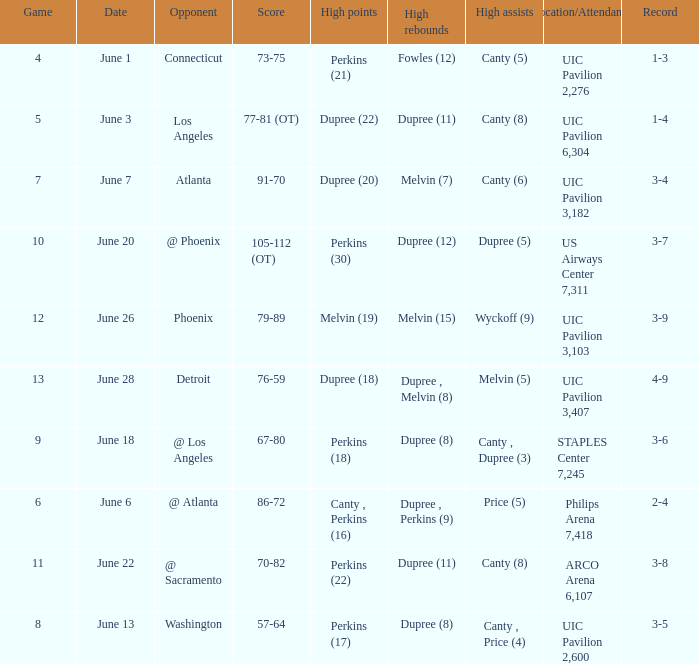Who had the most assists in the game that led to a 3-7 record? Dupree (5). 